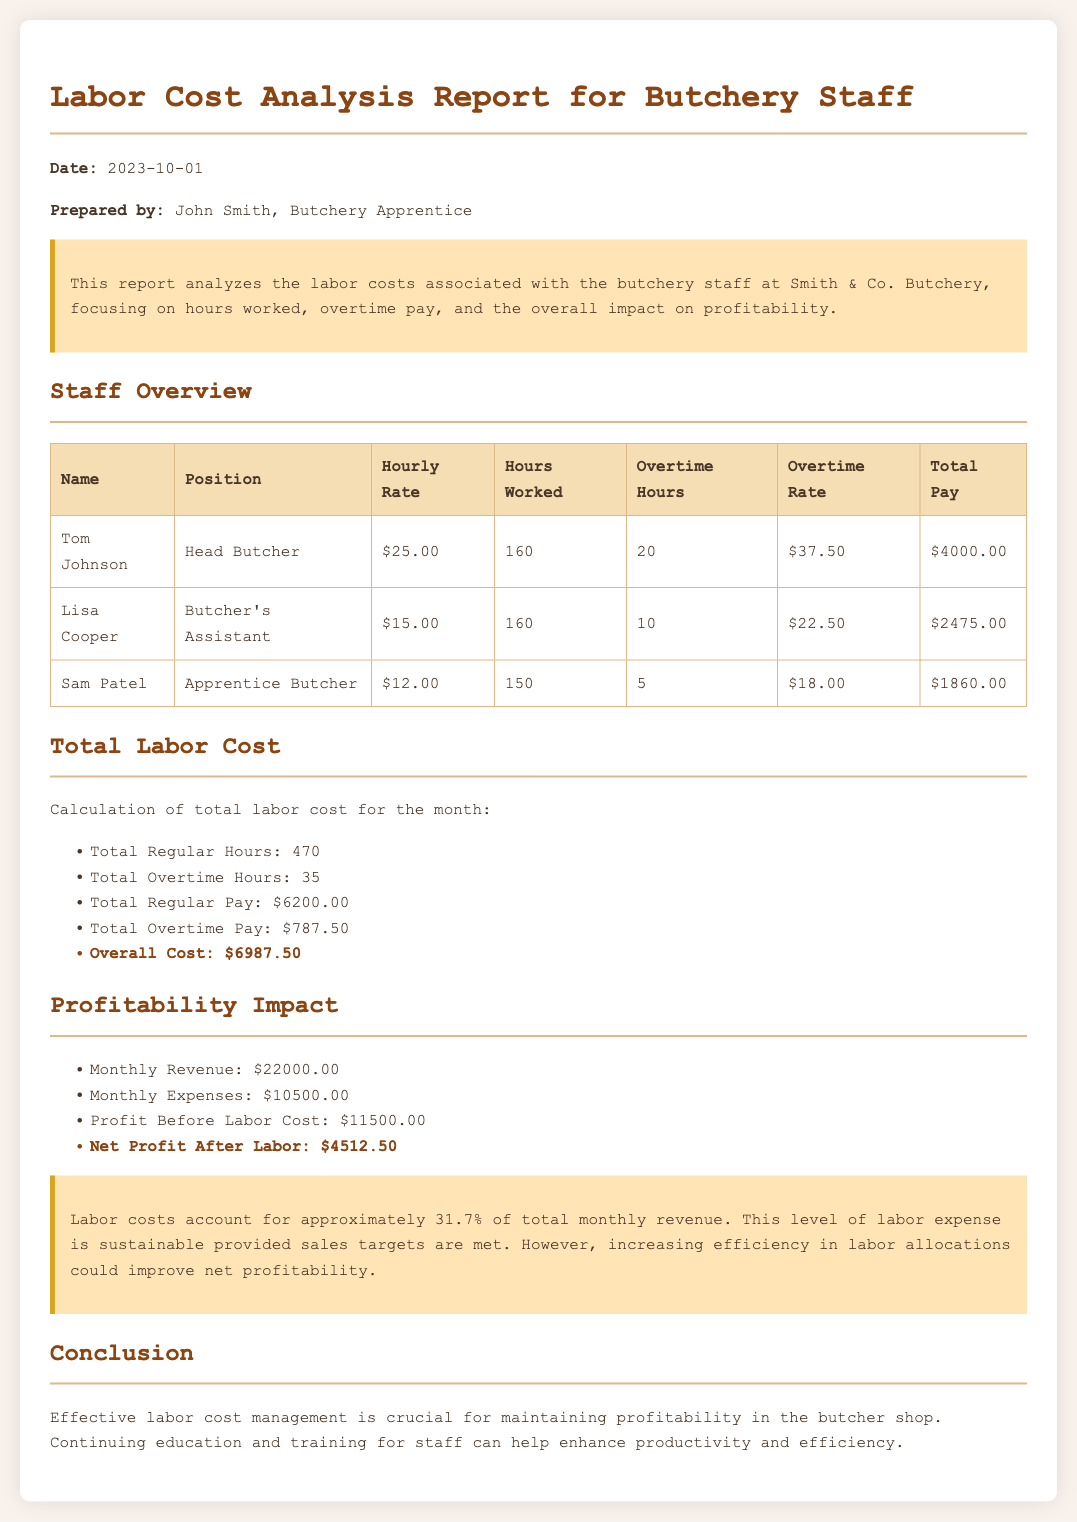What is the date of the report? The date of the report is provided in the document as the date it was prepared.
Answer: 2023-10-01 Who is the head butcher? The name of the head butcher is mentioned in the staff overview section of the document.
Answer: Tom Johnson What is the total regular pay? The total regular pay is calculated based on the hours worked and hourly rates of the staff.
Answer: $6200.00 How many total overtime hours were worked? The total overtime hours are listed in the summary of labor costs section in the report.
Answer: 35 What is the net profit after labor costs? The net profit after labor costs is calculated by subtracting the total labor costs from the profit before labor.
Answer: $4512.50 What percentage of the total monthly revenue do labor costs account for? The percentage of total monthly revenue attributed to labor costs is mentioned in the summary section of the report.
Answer: 31.7% What is Lisa Cooper's position? The position of Lisa Cooper is specified in the staff overview table of the document.
Answer: Butcher's Assistant What is Sam Patel's hourly rate? The hourly rate for Sam Patel is given in the staff overview section.
Answer: $12.00 